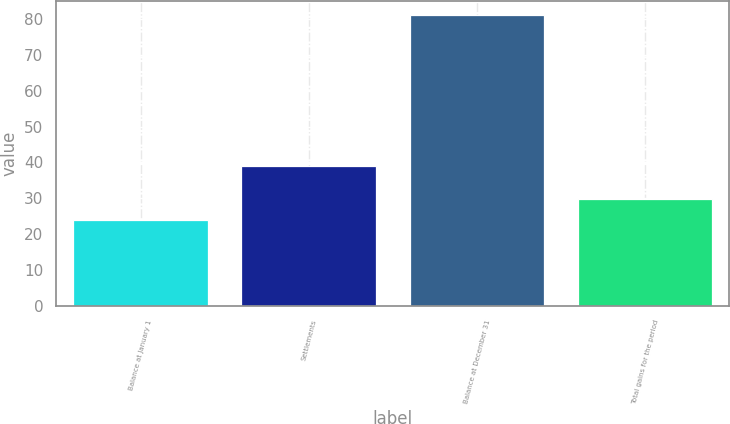Convert chart to OTSL. <chart><loc_0><loc_0><loc_500><loc_500><bar_chart><fcel>Balance at January 1<fcel>Settlements<fcel>Balance at December 31<fcel>Total gains for the period<nl><fcel>24<fcel>39<fcel>81<fcel>29.7<nl></chart> 